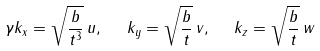<formula> <loc_0><loc_0><loc_500><loc_500>\gamma k _ { x } = \sqrt { \frac { b } { t ^ { 3 } } } \, u , \ \ k _ { y } = \sqrt { \frac { b } { t } } \, v , \ \ k _ { z } = \sqrt { \frac { b } { t } } \, w</formula> 